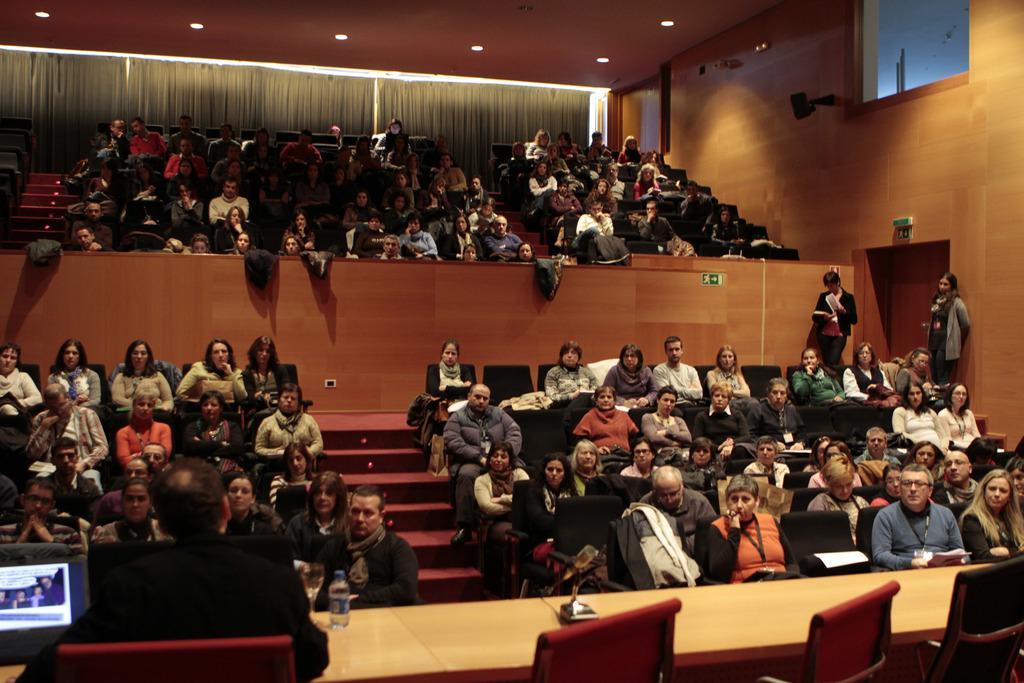Could you give a brief overview of what you see in this image? In this image, there are a few people. Among them, some people are sitting in chairs and some people are standing. We can see some stairs and the wall with some objects. We can also see some sign boards. We can see the roof with some lights. We can see a table with some objects like a screen, a bottle. There are a few chairs. We can see some curtains. 